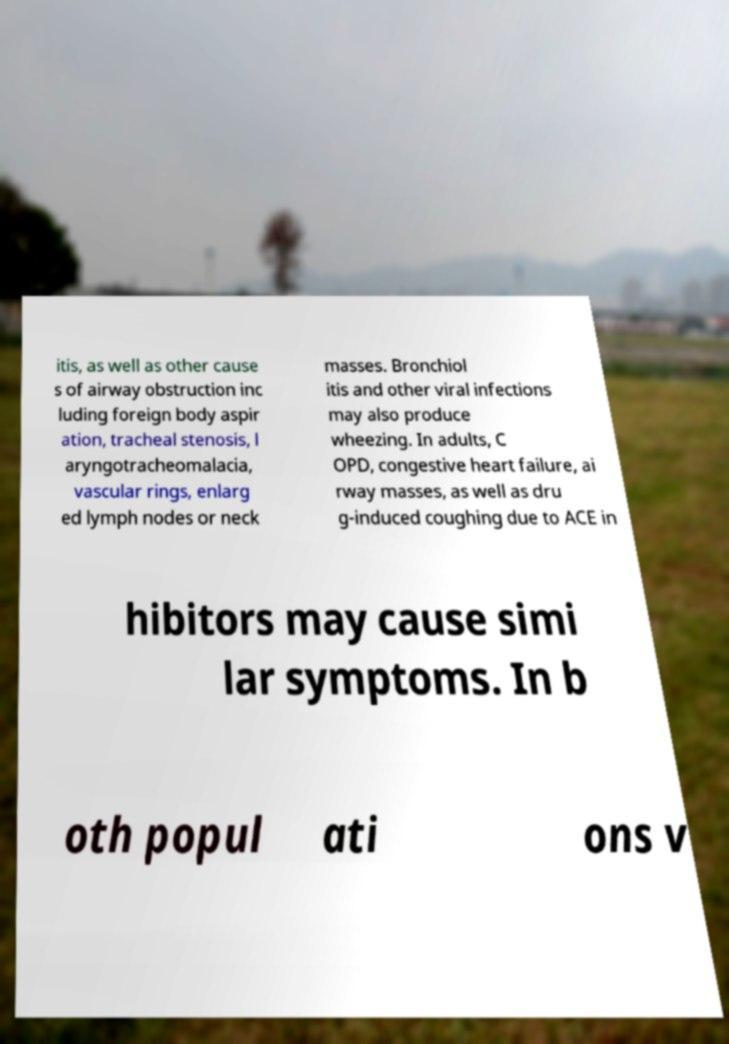Can you accurately transcribe the text from the provided image for me? itis, as well as other cause s of airway obstruction inc luding foreign body aspir ation, tracheal stenosis, l aryngotracheomalacia, vascular rings, enlarg ed lymph nodes or neck masses. Bronchiol itis and other viral infections may also produce wheezing. In adults, C OPD, congestive heart failure, ai rway masses, as well as dru g-induced coughing due to ACE in hibitors may cause simi lar symptoms. In b oth popul ati ons v 